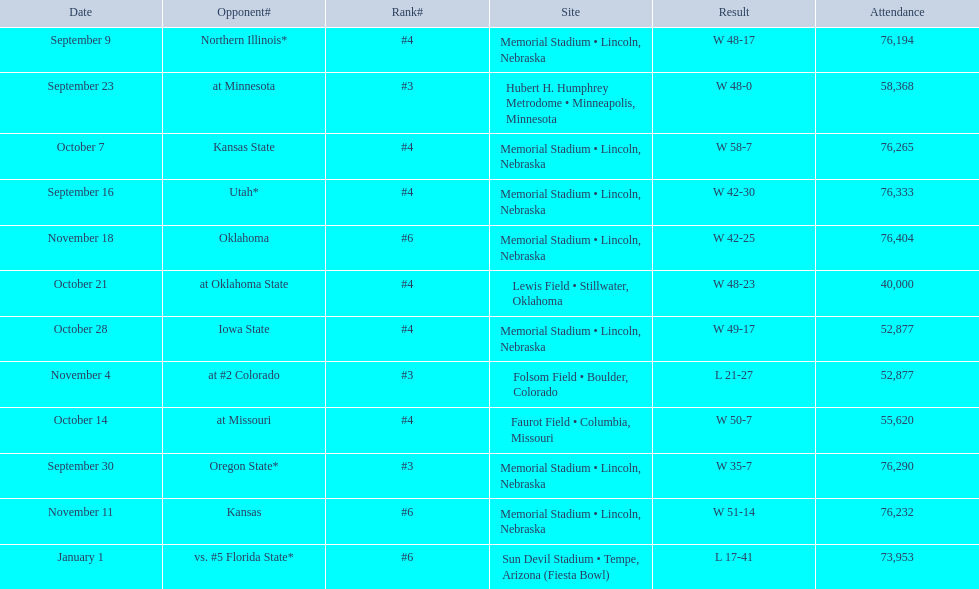What is the next site listed after lewis field? Memorial Stadium • Lincoln, Nebraska. 